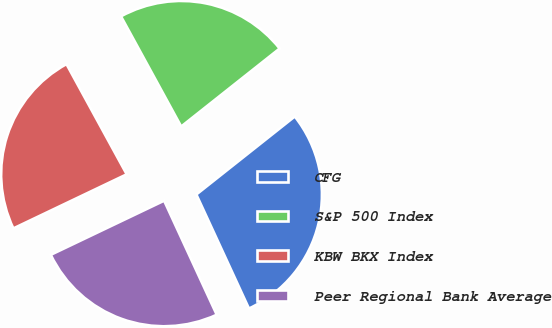Convert chart. <chart><loc_0><loc_0><loc_500><loc_500><pie_chart><fcel>CFG<fcel>S&P 500 Index<fcel>KBW BKX Index<fcel>Peer Regional Bank Average<nl><fcel>28.79%<fcel>22.3%<fcel>24.13%<fcel>24.79%<nl></chart> 